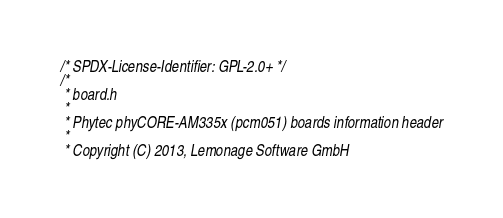Convert code to text. <code><loc_0><loc_0><loc_500><loc_500><_C_>/* SPDX-License-Identifier: GPL-2.0+ */
/*
 * board.h
 *
 * Phytec phyCORE-AM335x (pcm051) boards information header
 *
 * Copyright (C) 2013, Lemonage Software GmbH</code> 